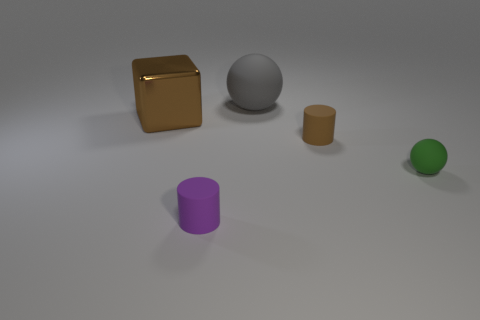There is a matte thing that is the same color as the big block; what size is it?
Give a very brief answer. Small. How many brown matte objects are in front of the rubber ball that is right of the brown thing to the right of the large metallic object?
Ensure brevity in your answer.  0. There is a big metal cube; is it the same color as the cylinder that is behind the tiny purple rubber cylinder?
Offer a very short reply. Yes. What number of objects are either matte spheres that are left of the green sphere or small things behind the small purple cylinder?
Keep it short and to the point. 3. Is the number of large brown metallic objects that are left of the brown rubber object greater than the number of gray rubber things that are in front of the big brown block?
Provide a succinct answer. Yes. What material is the large thing on the left side of the ball that is behind the rubber sphere to the right of the tiny brown cylinder?
Make the answer very short. Metal. There is a rubber thing right of the tiny brown cylinder; is it the same shape as the brown thing that is left of the big matte sphere?
Your answer should be very brief. No. Are there any red objects that have the same size as the green object?
Offer a terse response. No. What number of purple things are either small objects or blocks?
Your answer should be very brief. 1. How many blocks have the same color as the shiny thing?
Your answer should be compact. 0. 